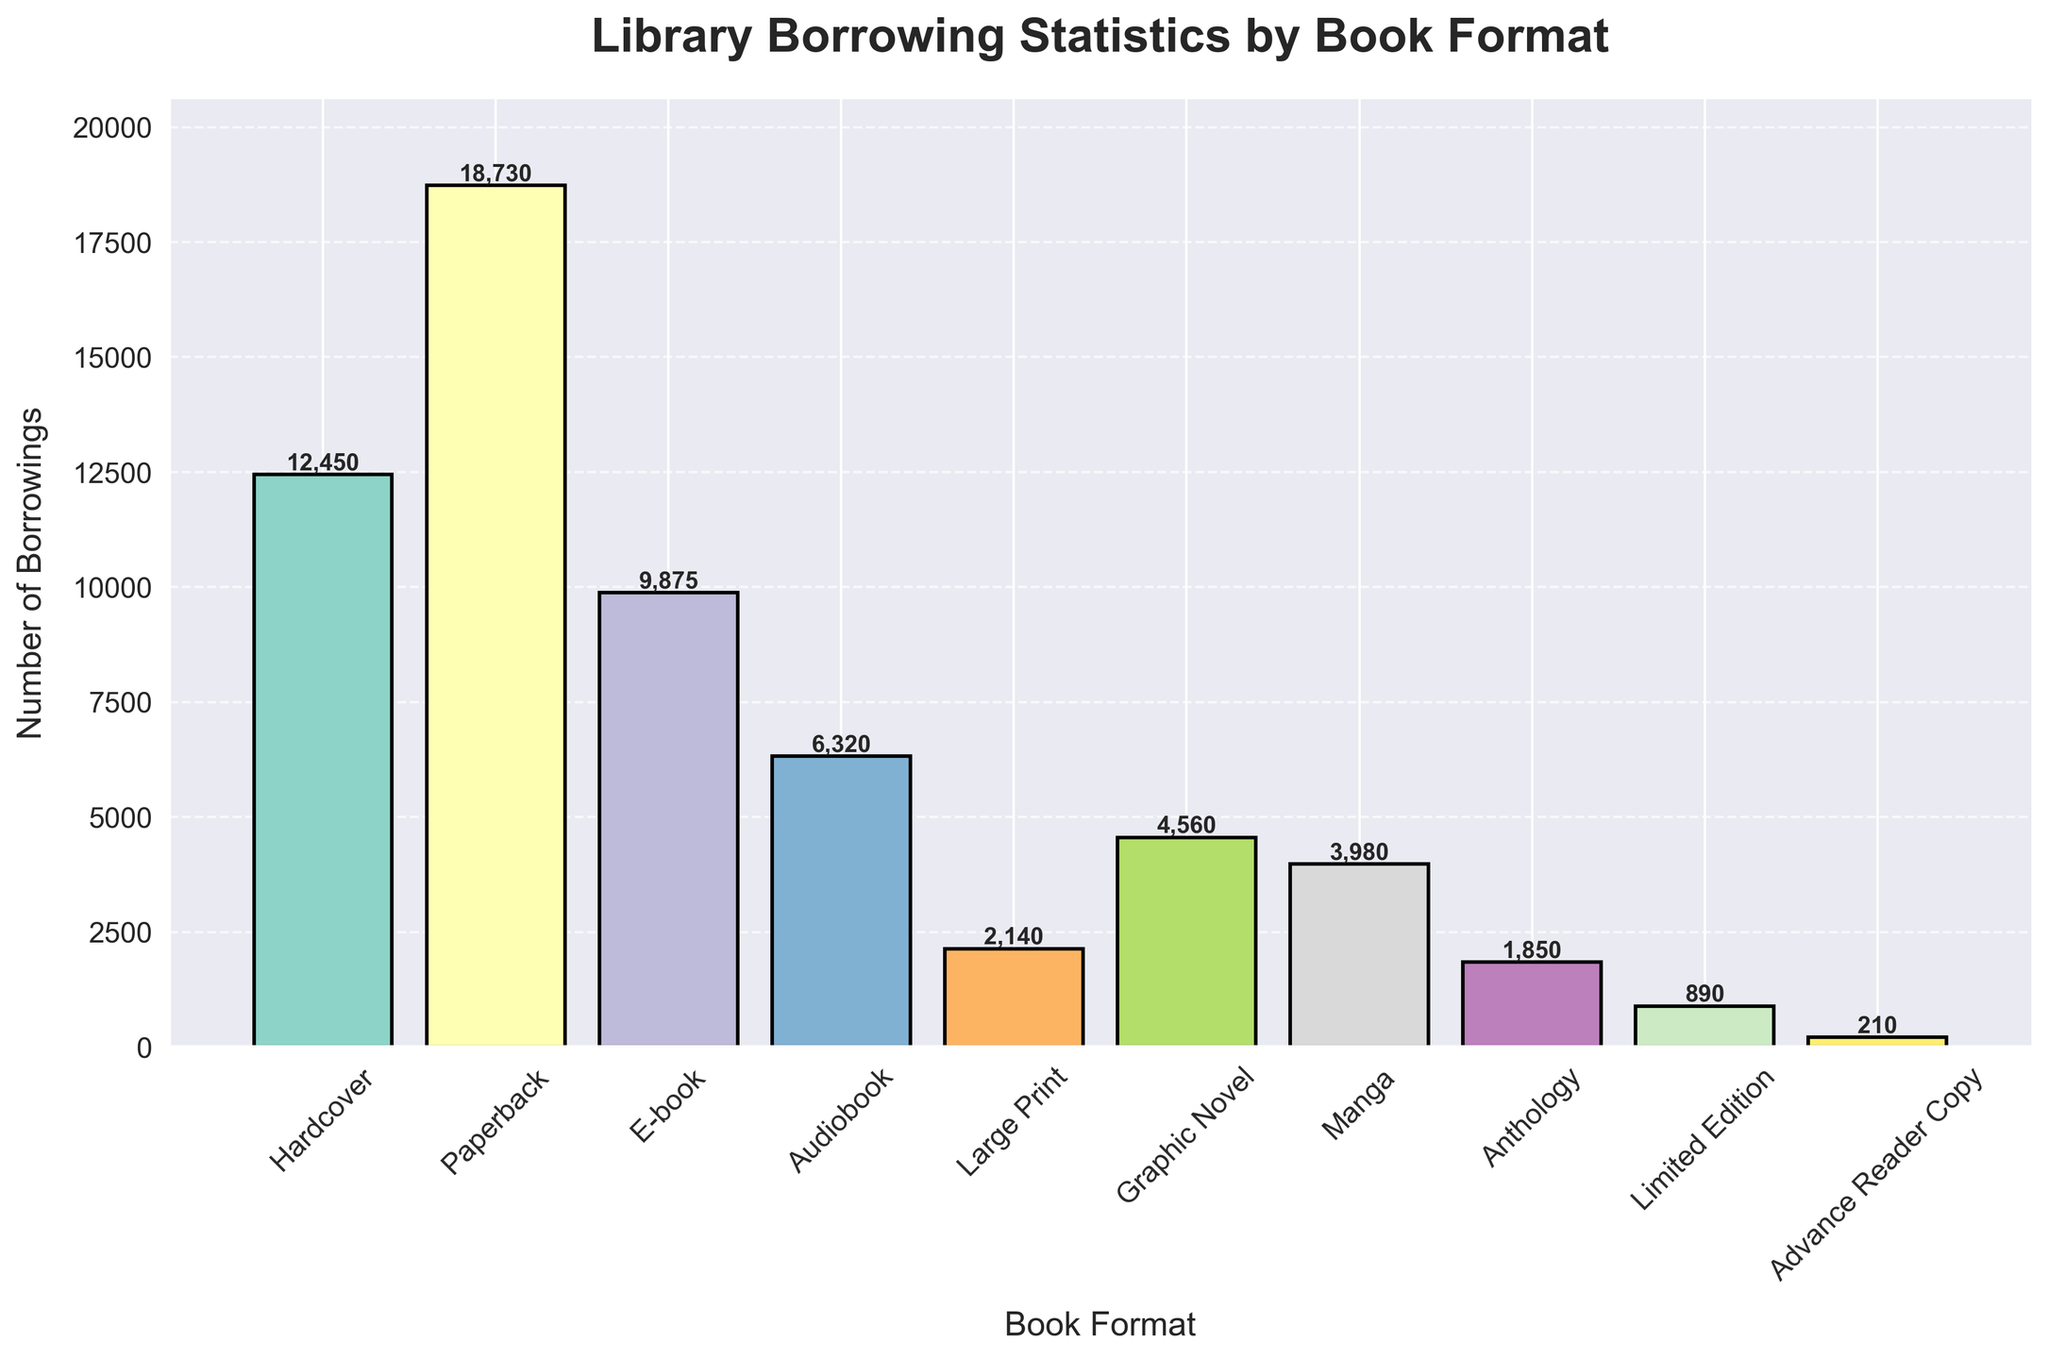Which book format has the highest number of borrowings? To find this, look at the bar with the greatest height. The tallest bar represents the Paperback format.
Answer: Paperback Which book format has the lowest number of borrowings? Identify the bar with the smallest height. The shortest bar represents the Advance Reader Copy format.
Answer: Advance Reader Copy How many more borrowings does the Hardcover format have than the Audiobook format? Subtract the borrowings of Audiobook from Hardcover: 12450 - 6320 = 6130
Answer: 6130 What is the total number of borrowings for Hardcover and E-book formats? Add the borrowings of Hardcover and E-book: 12450 + 9875 = 22325
Answer: 22325 What is the average number of borrowings for Graphic Novel, Manga, and Anthology formats? Add the borrowings and divide by the number of formats: (4560 + 3980 + 1850) / 3 = 10390 / 3 ≈ 3463.33
Answer: 3463.33 Did more people borrow Large Print books or Graphic Novels? Compare the heights of the bars for Large Print and Graphic Novel. The height for Graphic Novel is higher than Large Print.
Answer: Graphic Novel Is the number of borrowings for Anthology greater than for Manga? Compare the heights of the bars for Anthology and Manga. The height for Anthology is less than Manga.
Answer: No How does the number of borrowings for E-books compare to Audiobooks? Compare the heights of the bars for E-books and Audiobooks. The height of the bar for E-books (9875) is greater than Audiobooks (6320).
Answer: E-books have more borrowings What percentage of the total borrowings does the Paperback format represent? First, calculate the total borrowings of all formats. Then, divide the borrowings of the Paperback format by this total and multiply by 100.
Total borrowings = 12450 + 18730 + 9875 + 6320 + 2140 + 4560 + 3980 + 1850 + 890 + 210 = 61205
Percentage = (18730 / 61205) * 100 ≈ 30.61%
Answer: 30.61% Which two formats have the closest number of borrowings? Compare the borrowings of each format and find the pair with the smallest difference. Large Print (2140) and Manga (3980) are the two formats with the closest difference (3980 - 2140 = 1840).
Answer: Large Print and Manga 